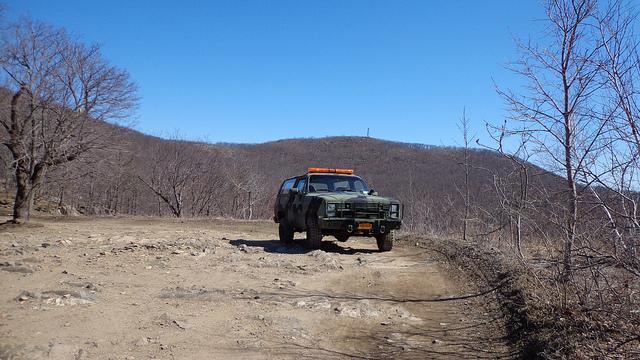Does this look like a recently paved road?
Keep it brief. No. What season is this?
Quick response, please. Winter. Who was the maker of the truck?
Write a very short answer. Jeep. What type of vehicle is in the picture?
Answer briefly. Suv. 